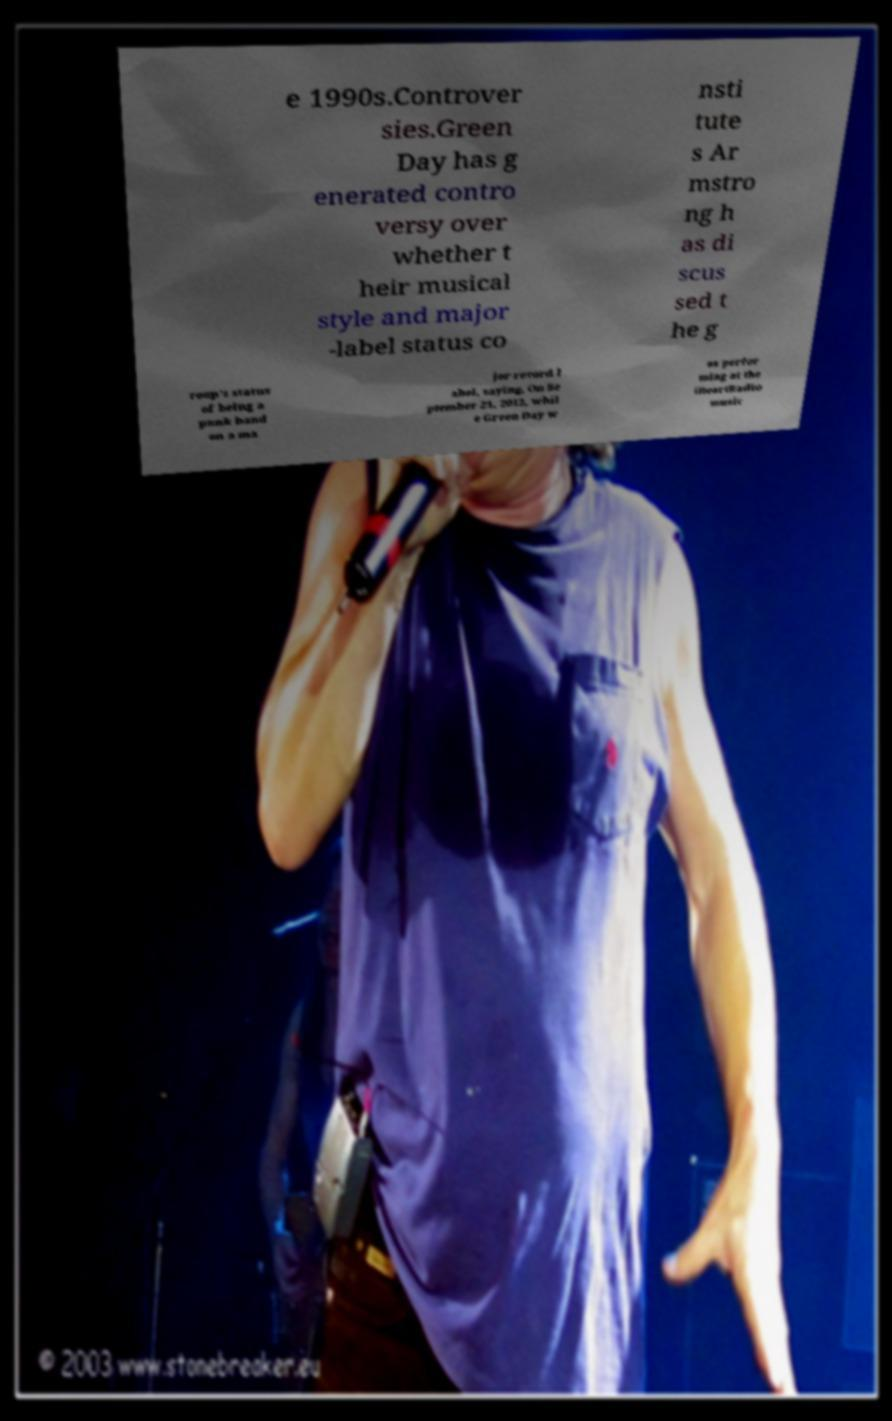What messages or text are displayed in this image? I need them in a readable, typed format. e 1990s.Controver sies.Green Day has g enerated contro versy over whether t heir musical style and major -label status co nsti tute s Ar mstro ng h as di scus sed t he g roup's status of being a punk band on a ma jor record l abel, saying, On Se ptember 21, 2012, whil e Green Day w as perfor ming at the iHeartRadio music 